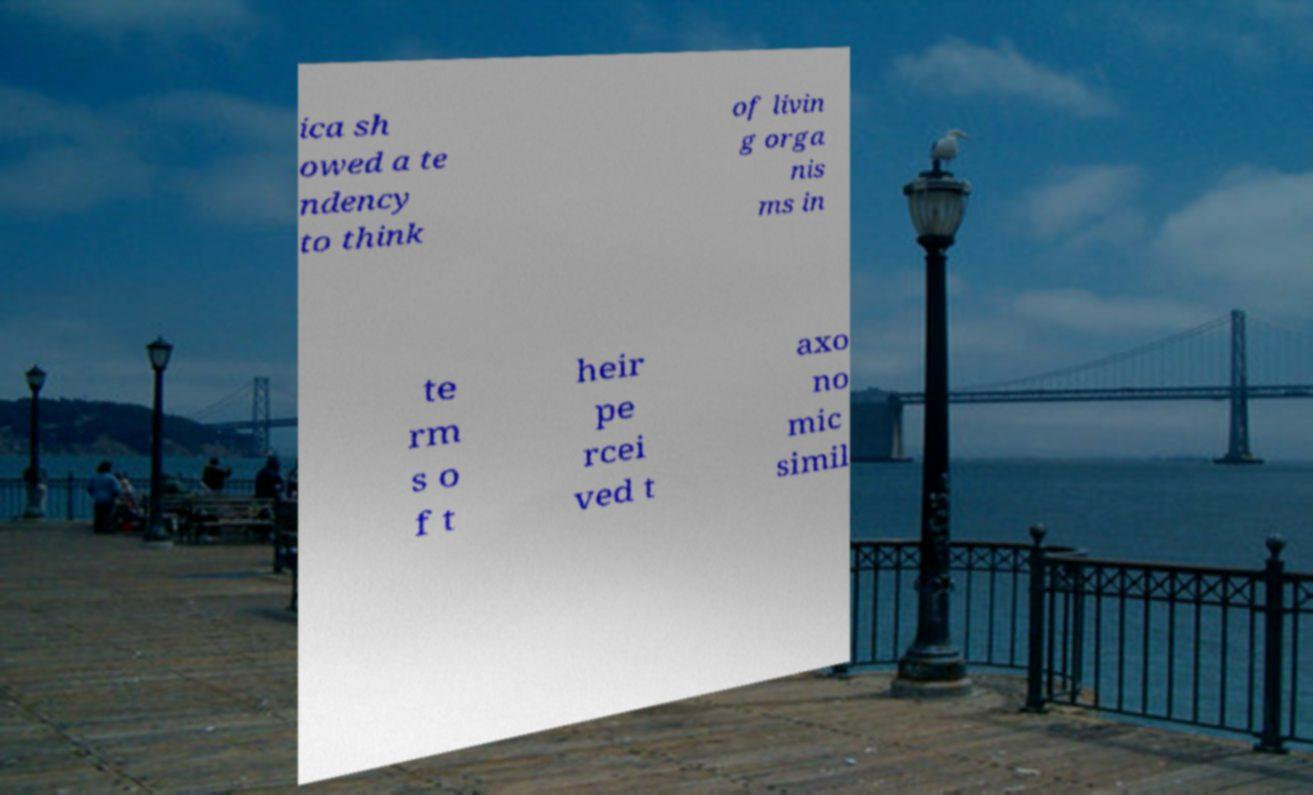Could you assist in decoding the text presented in this image and type it out clearly? ica sh owed a te ndency to think of livin g orga nis ms in te rm s o f t heir pe rcei ved t axo no mic simil 